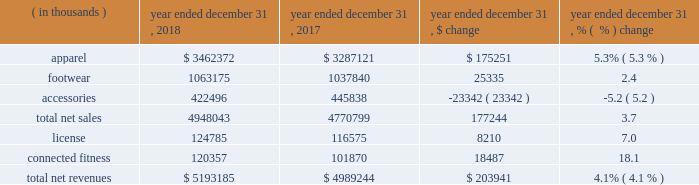Consolidated results of operations year ended december 31 , 2018 compared to year ended december 31 , 2017 net revenues increased $ 203.9 million , or 4.1% ( 4.1 % ) , to $ 5193.2 million in 2018 from $ 4989.2 million in 2017 .
Net revenues by product category are summarized below: .
The increase in net sales was driven primarily by : 2022 apparel unit sales growth driven by the train category ; and 2022 footwear unit sales growth , led by the run category .
The increase was partially offset by unit sales decline in accessories .
License revenues increased $ 8.2 million , or 7.0% ( 7.0 % ) , to $ 124.8 million in 2018 from $ 116.6 million in 2017 .
Connected fitness revenue increased $ 18.5 million , or 18.1% ( 18.1 % ) , to $ 120.4 million in 2018 from $ 101.9 million in 2017 primarily driven by increased subscribers on our fitness applications .
Gross profit increased $ 89.1 million to $ 2340.5 million in 2018 from $ 2251.4 million in 2017 .
Gross profit as a percentage of net revenues , or gross margin , was unchanged at 45.1% ( 45.1 % ) in 2018 compared to 2017 .
Gross profit percentage was favorably impacted by lower promotional activity , improvements in product cost , lower air freight , higher proportion of international and connected fitness revenue and changes in foreign currency ; these favorable impacts were offset by channel mix including higher sales to our off-price channel and restructuring related charges .
With the exception of improvements in product input costs and air freight improvements , we do not expect these trends to have a material impact on the full year 2019 .
Selling , general and administrative expenses increased $ 82.8 million to $ 2182.3 million in 2018 from $ 2099.5 million in 2017 .
As a percentage of net revenues , selling , general and administrative expenses decreased slightly to 42.0% ( 42.0 % ) in 2018 from 42.1% ( 42.1 % ) in 2017 .
Selling , general and administrative expense was impacted by the following : 2022 marketing costs decreased $ 21.3 million to $ 543.8 million in 2018 from $ 565.1 million in 2017 .
This decrease was primarily due to restructuring efforts , resulting in lower compensation and contractual sports marketing .
This decrease was partially offset by higher costs in connection with brand marketing campaigns and increased marketing investments with the growth of our international business .
As a percentage of net revenues , marketing costs decreased to 10.5% ( 10.5 % ) in 2018 from 11.3% ( 11.3 % ) in 2017 .
2022 other costs increased $ 104.1 million to $ 1638.5 million in 2018 from $ 1534.4 million in 2017 .
This increase was primarily due to higher incentive compensation expense and higher costs incurred for the continued expansion of our direct to consumer distribution channel and international business .
As a percentage of net revenues , other costs increased to 31.6% ( 31.6 % ) in 2018 from 30.8% ( 30.8 % ) in 2017 .
Restructuring and impairment charges increased $ 59.1 million to $ 183.1 million from $ 124.0 million in 2017 .
Refer to the restructuring plans section above for a summary of charges .
Income ( loss ) from operations decreased $ 52.8 million , or 189.9% ( 189.9 % ) , to a loss of $ 25.0 million in 2018 from income of $ 27.8 million in 2017 .
As a percentage of net revenues , income from operations decreased to a loss of 0.4% ( 0.4 % ) in 2018 from income of 0.5% ( 0.5 % ) in 2017 .
Income from operations for the year ended december 31 , 2018 was negatively impacted by $ 203.9 million of restructuring , impairment and related charges in connection with the 2018 restructuring plan .
Income from operations for the year ended december 31 , 2017 was negatively impacted by $ 129.1 million of restructuring , impairment and related charges in connection with the 2017 restructuring plan .
Interest expense , net decreased $ 0.9 million to $ 33.6 million in 2018 from $ 34.5 million in 2017. .
What was connected fitness as a percentage of total net revenue in 2017? 
Computations: (101870 / 4989244)
Answer: 0.02042. 